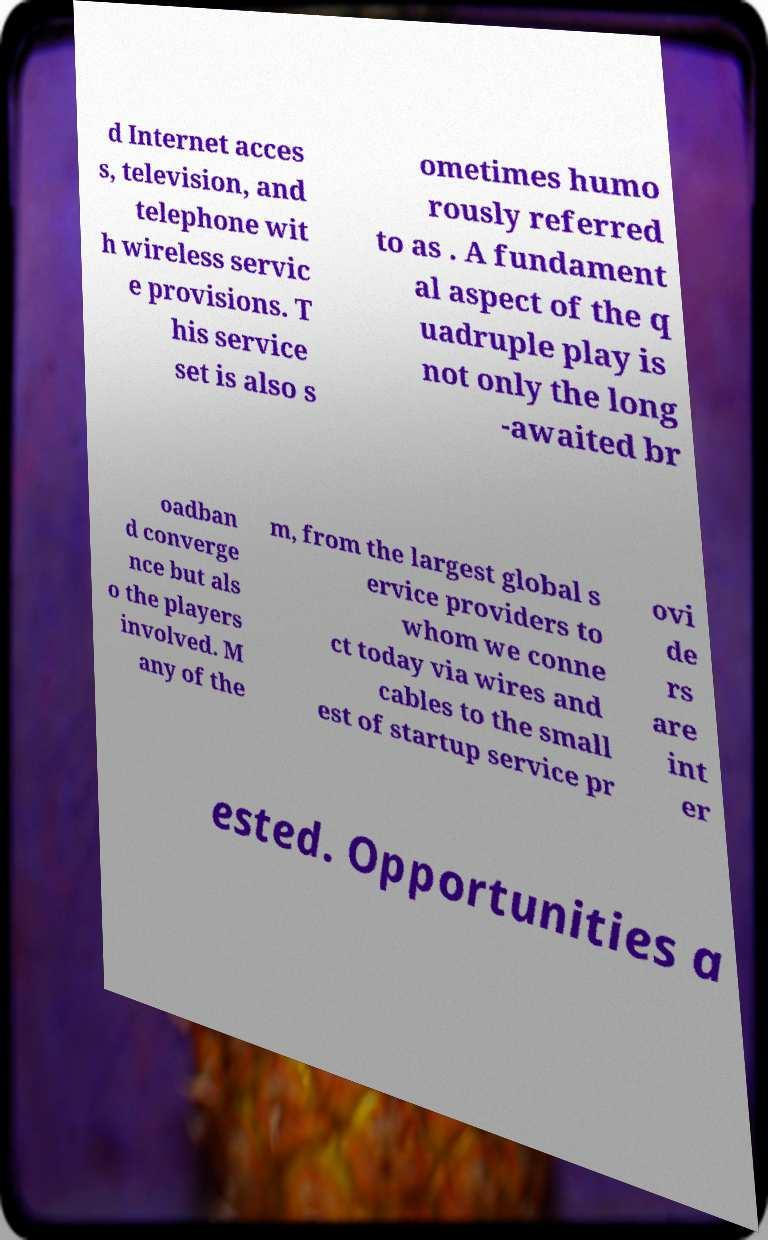Can you read and provide the text displayed in the image?This photo seems to have some interesting text. Can you extract and type it out for me? d Internet acces s, television, and telephone wit h wireless servic e provisions. T his service set is also s ometimes humo rously referred to as . A fundament al aspect of the q uadruple play is not only the long -awaited br oadban d converge nce but als o the players involved. M any of the m, from the largest global s ervice providers to whom we conne ct today via wires and cables to the small est of startup service pr ovi de rs are int er ested. Opportunities a 